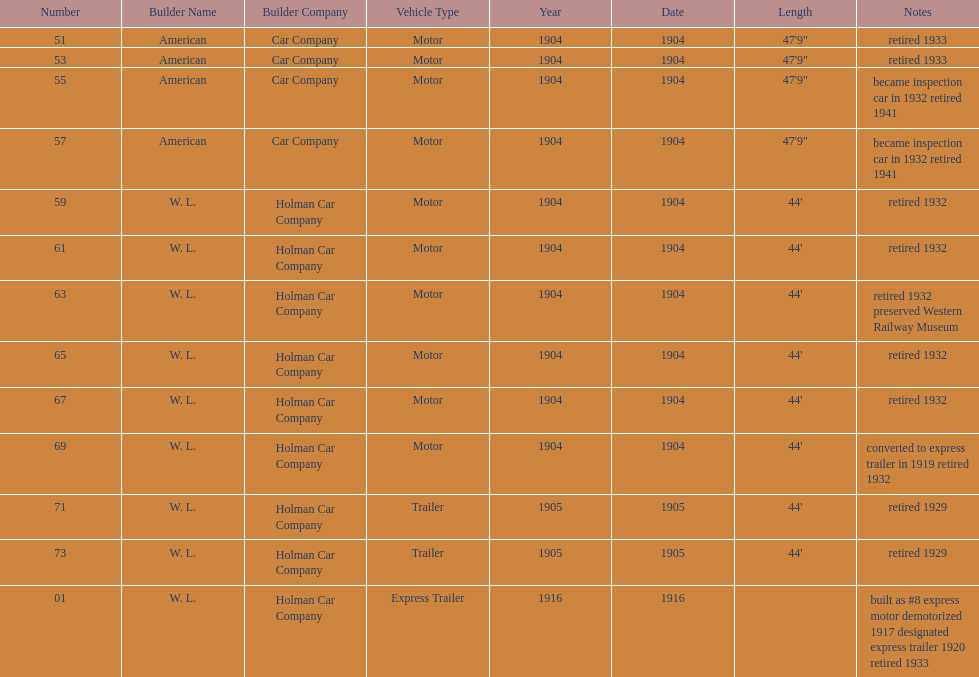How long did it take number 71 to retire? 24. 